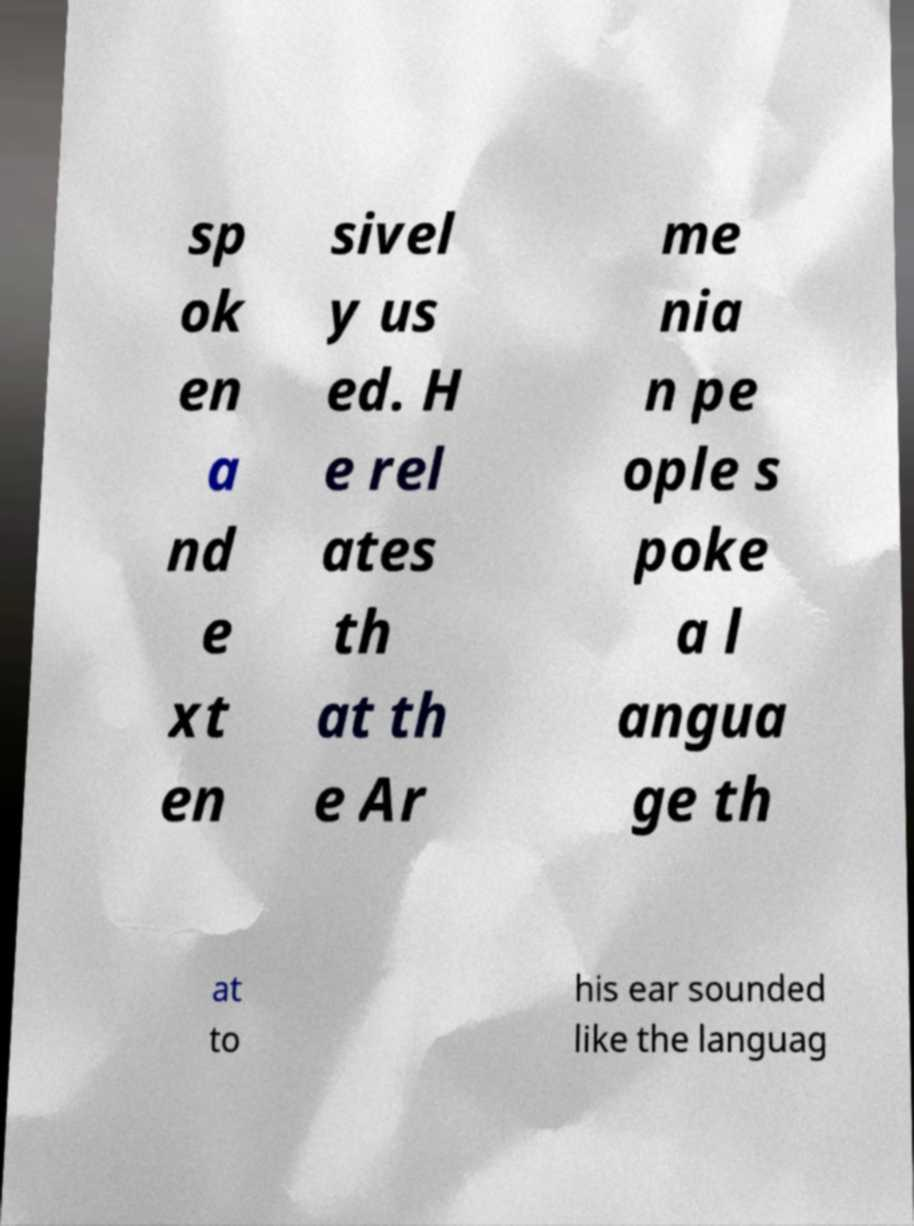For documentation purposes, I need the text within this image transcribed. Could you provide that? sp ok en a nd e xt en sivel y us ed. H e rel ates th at th e Ar me nia n pe ople s poke a l angua ge th at to his ear sounded like the languag 